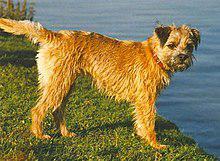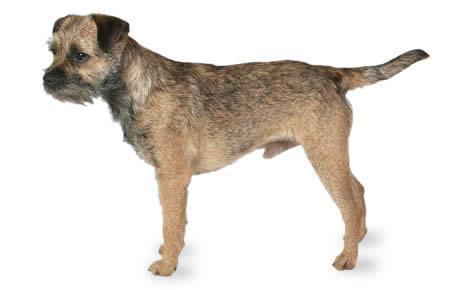The first image is the image on the left, the second image is the image on the right. Given the left and right images, does the statement "At least one dog in the left image is looking towards the left." hold true? Answer yes or no. No. The first image is the image on the left, the second image is the image on the right. For the images shown, is this caption "One of the dogs has its tongue visible without its teeth showing." true? Answer yes or no. No. The first image is the image on the left, the second image is the image on the right. For the images displayed, is the sentence "All images show one dog that is standing." factually correct? Answer yes or no. Yes. The first image is the image on the left, the second image is the image on the right. Evaluate the accuracy of this statement regarding the images: "A single dog is standing on all fours in the image on the left.". Is it true? Answer yes or no. Yes. 